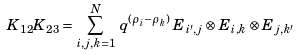<formula> <loc_0><loc_0><loc_500><loc_500>K _ { 1 2 } K _ { 2 3 } = \sum _ { i , j , k = 1 } ^ { N } \, q ^ { ( \rho _ { i } - \rho _ { k } ) } \, E _ { i ^ { \prime } , j } \otimes E _ { i , k } \otimes E _ { j , k ^ { \prime } }</formula> 